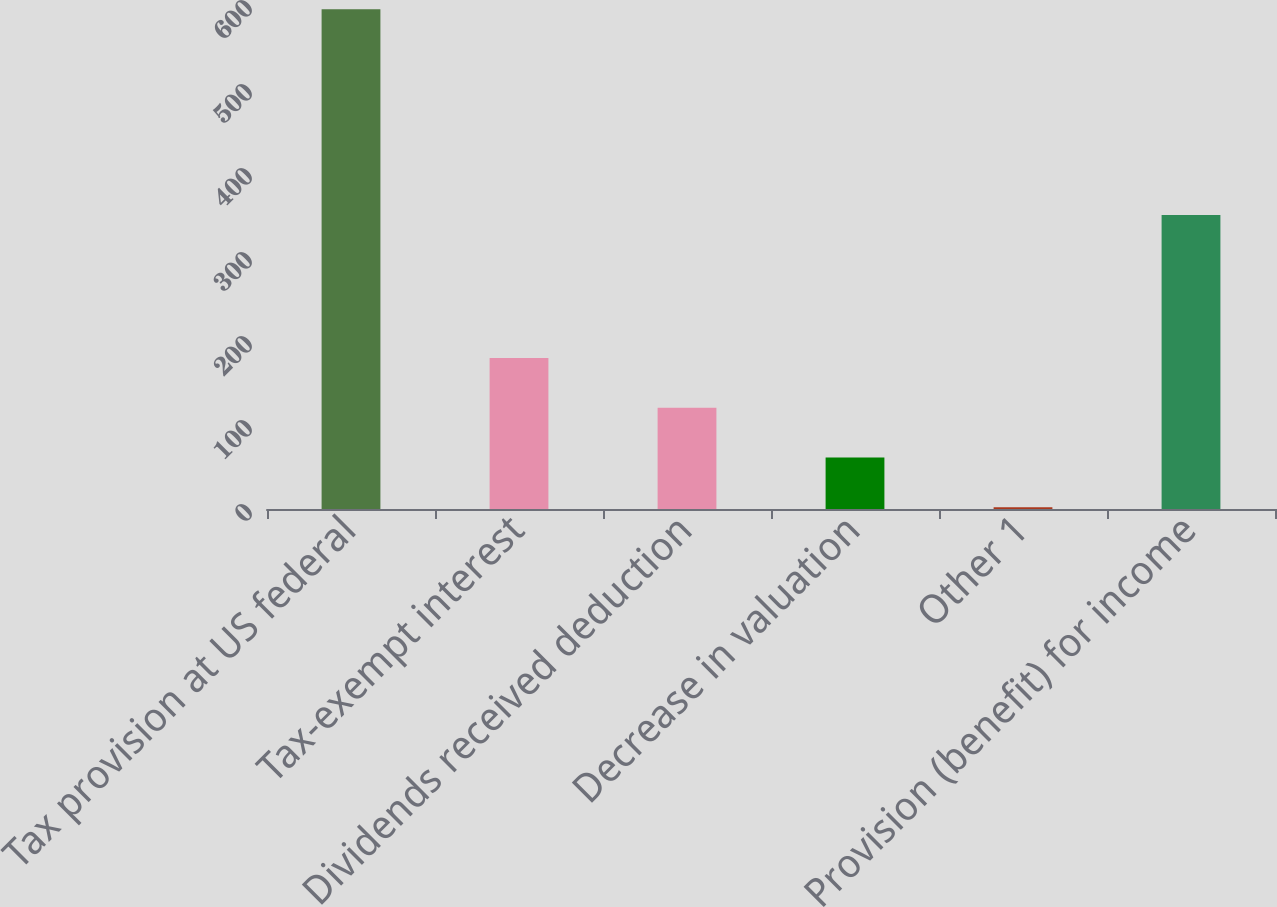Convert chart to OTSL. <chart><loc_0><loc_0><loc_500><loc_500><bar_chart><fcel>Tax provision at US federal<fcel>Tax-exempt interest<fcel>Dividends received deduction<fcel>Decrease in valuation<fcel>Other 1<fcel>Provision (benefit) for income<nl><fcel>595<fcel>179.9<fcel>120.6<fcel>61.3<fcel>2<fcel>350<nl></chart> 